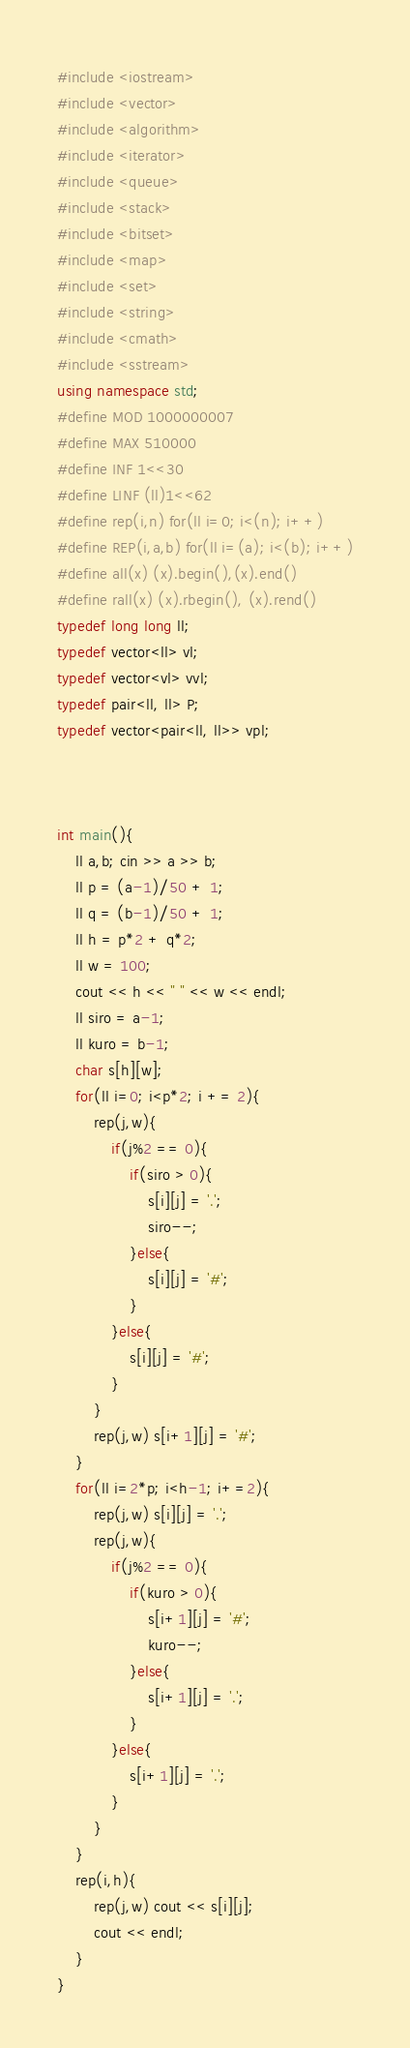<code> <loc_0><loc_0><loc_500><loc_500><_C++_>#include <iostream>
#include <vector>
#include <algorithm>
#include <iterator>
#include <queue>
#include <stack>
#include <bitset>
#include <map>
#include <set>
#include <string>
#include <cmath>
#include <sstream>
using namespace std;
#define MOD 1000000007
#define MAX 510000
#define INF 1<<30
#define LINF (ll)1<<62
#define rep(i,n) for(ll i=0; i<(n); i++)
#define REP(i,a,b) for(ll i=(a); i<(b); i++)
#define all(x) (x).begin(),(x).end()
#define rall(x) (x).rbegin(), (x).rend()
typedef long long ll;
typedef vector<ll> vl;
typedef vector<vl> vvl;
typedef pair<ll, ll> P;
typedef vector<pair<ll, ll>> vpl;



int main(){
    ll a,b; cin >> a >> b;
    ll p = (a-1)/50 + 1;
    ll q = (b-1)/50 + 1;
    ll h = p*2 + q*2;
    ll w = 100;
    cout << h << " " << w << endl;
    ll siro = a-1;
    ll kuro = b-1;
    char s[h][w];
    for(ll i=0; i<p*2; i += 2){
        rep(j,w){
            if(j%2 == 0){
                if(siro > 0){
                    s[i][j] = '.';
                    siro--;
                }else{
                    s[i][j] = '#';
                }
            }else{
                s[i][j] = '#';
            }
        }
        rep(j,w) s[i+1][j] = '#';
    }
    for(ll i=2*p; i<h-1; i+=2){
        rep(j,w) s[i][j] = '.';
        rep(j,w){
            if(j%2 == 0){
                if(kuro > 0){
                    s[i+1][j] = '#';
                    kuro--;
                }else{
                    s[i+1][j] = '.';
                }
            }else{
                s[i+1][j] = '.';
            }
        }
    }
    rep(i,h){
        rep(j,w) cout << s[i][j];
        cout << endl;
    }
}
</code> 